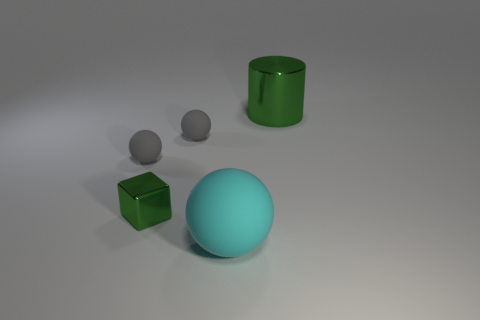What number of objects are shiny things that are to the left of the big cyan matte object or large matte spheres?
Provide a succinct answer. 2. There is a small thing that is the same material as the large cylinder; what shape is it?
Offer a very short reply. Cube. What number of big green metallic things are the same shape as the large rubber thing?
Give a very brief answer. 0. What is the large green cylinder made of?
Keep it short and to the point. Metal. Is the color of the large matte object the same as the thing to the right of the big cyan matte sphere?
Your answer should be compact. No. How many blocks are large metallic objects or big things?
Your response must be concise. 0. The large object that is behind the green metal cube is what color?
Give a very brief answer. Green. There is a big thing that is the same color as the metallic cube; what is its shape?
Offer a very short reply. Cylinder. How many gray rubber spheres are the same size as the cyan ball?
Make the answer very short. 0. There is a metal thing that is right of the cyan ball; does it have the same shape as the gray object that is to the right of the small green metallic cube?
Offer a very short reply. No. 